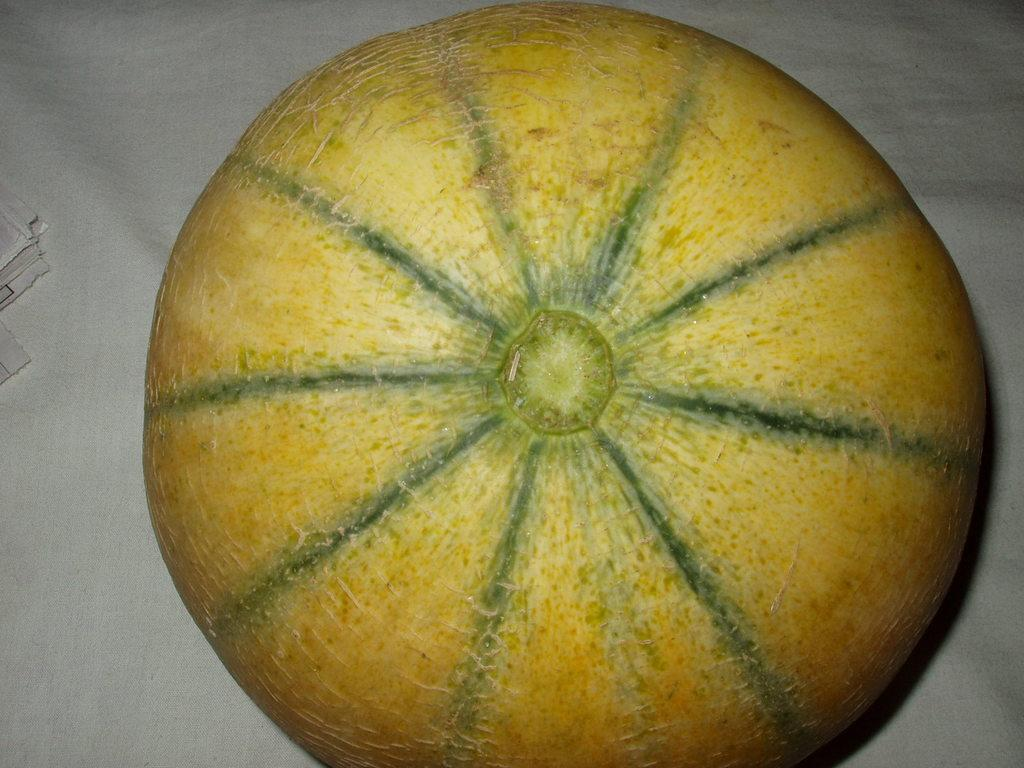What type of fruit is in the image? There is a cantaloupe melon in the image. What is the cantaloupe melon placed on? The cantaloupe melon is placed on a white surface. How many yaks are present in the image? There are no yaks present in the image. What type of dolls can be seen interacting with the cantaloupe melon in the image? There are no dolls present in the image, and the cantaloupe melon is not interacting with any objects. 